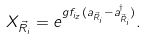<formula> <loc_0><loc_0><loc_500><loc_500>X _ { \vec { R } _ { i } } = e ^ { g f _ { i _ { z } } ( a _ { \vec { R } _ { i } } - a ^ { \dag } _ { \vec { R } _ { i } } ) } . \\</formula> 